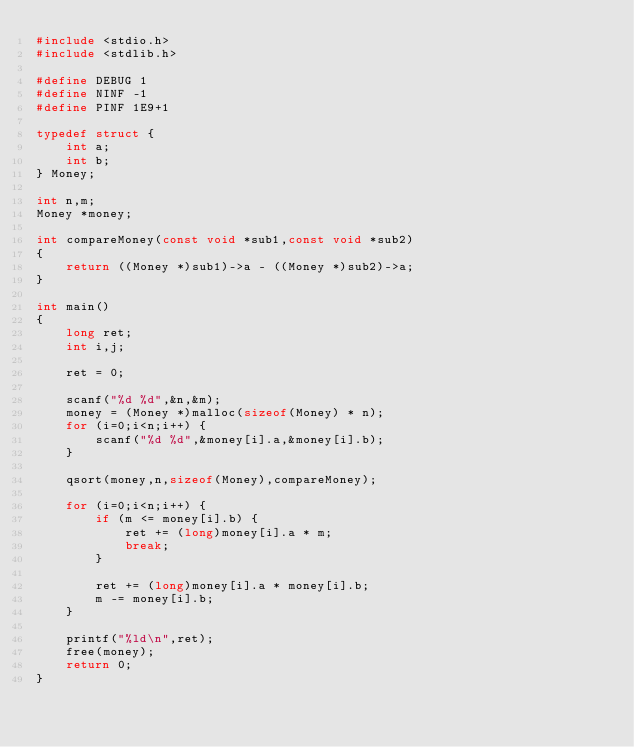<code> <loc_0><loc_0><loc_500><loc_500><_C_>#include <stdio.h>
#include <stdlib.h>

#define DEBUG 1
#define NINF -1
#define PINF 1E9+1

typedef struct {
	int a;
	int b;
} Money;

int n,m;
Money *money;

int compareMoney(const void *sub1,const void *sub2)
{
	return ((Money *)sub1)->a - ((Money *)sub2)->a;
}

int main()
{
	long ret;
	int i,j;

	ret = 0;

	scanf("%d %d",&n,&m);
	money = (Money *)malloc(sizeof(Money) * n);
	for (i=0;i<n;i++) {
		scanf("%d %d",&money[i].a,&money[i].b);
	}
	
	qsort(money,n,sizeof(Money),compareMoney);

	for (i=0;i<n;i++) {
		if (m <= money[i].b) {
			ret += (long)money[i].a * m;
			break;
		}

		ret += (long)money[i].a * money[i].b;
		m -= money[i].b;
	}

	printf("%ld\n",ret);
	free(money);
	return 0;
}
</code> 